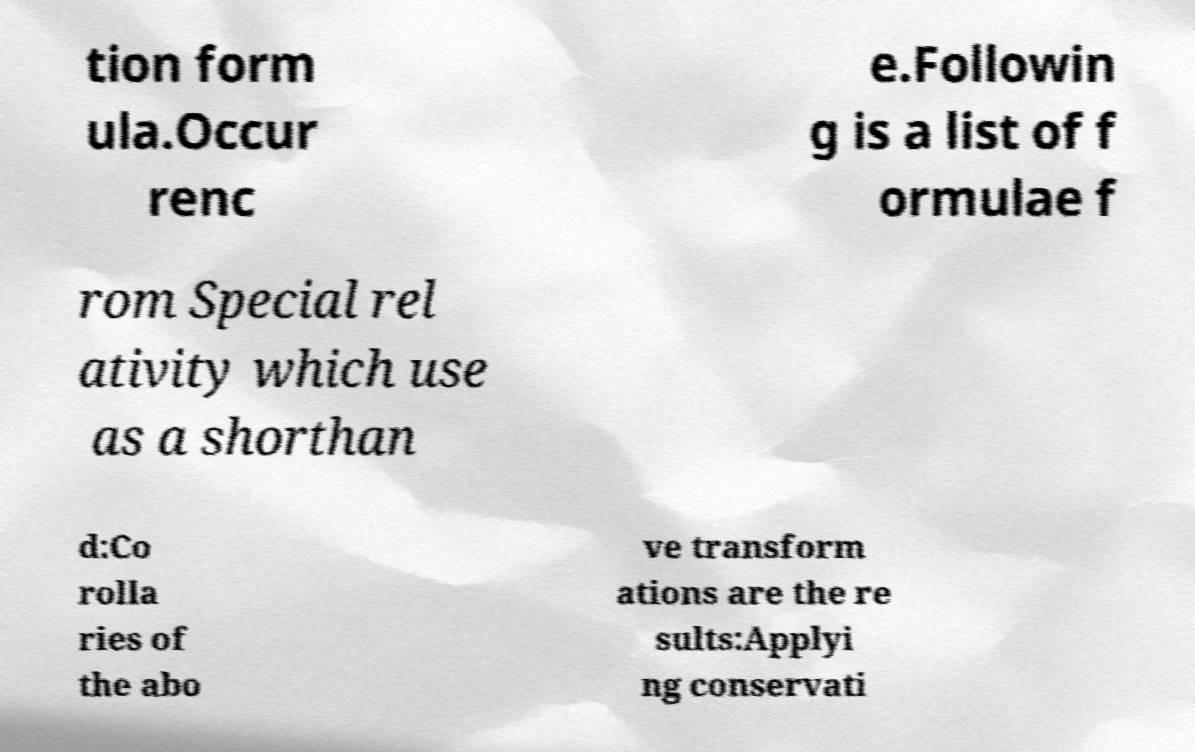Please identify and transcribe the text found in this image. tion form ula.Occur renc e.Followin g is a list of f ormulae f rom Special rel ativity which use as a shorthan d:Co rolla ries of the abo ve transform ations are the re sults:Applyi ng conservati 